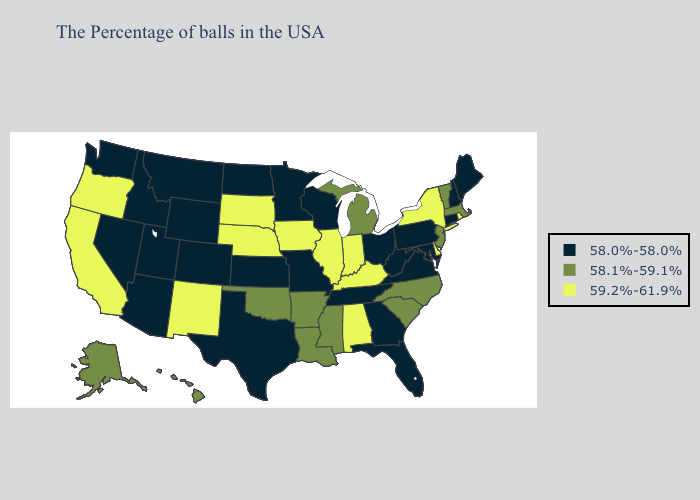What is the highest value in the USA?
Quick response, please. 59.2%-61.9%. What is the highest value in states that border Alabama?
Concise answer only. 58.1%-59.1%. Name the states that have a value in the range 59.2%-61.9%?
Be succinct. Rhode Island, New York, Delaware, Kentucky, Indiana, Alabama, Illinois, Iowa, Nebraska, South Dakota, New Mexico, California, Oregon. Name the states that have a value in the range 59.2%-61.9%?
Be succinct. Rhode Island, New York, Delaware, Kentucky, Indiana, Alabama, Illinois, Iowa, Nebraska, South Dakota, New Mexico, California, Oregon. Name the states that have a value in the range 58.1%-59.1%?
Write a very short answer. Massachusetts, Vermont, New Jersey, North Carolina, South Carolina, Michigan, Mississippi, Louisiana, Arkansas, Oklahoma, Alaska, Hawaii. Among the states that border South Dakota , does Minnesota have the lowest value?
Answer briefly. Yes. What is the lowest value in states that border New Mexico?
Quick response, please. 58.0%-58.0%. Name the states that have a value in the range 58.0%-58.0%?
Write a very short answer. Maine, New Hampshire, Connecticut, Maryland, Pennsylvania, Virginia, West Virginia, Ohio, Florida, Georgia, Tennessee, Wisconsin, Missouri, Minnesota, Kansas, Texas, North Dakota, Wyoming, Colorado, Utah, Montana, Arizona, Idaho, Nevada, Washington. Among the states that border Ohio , which have the highest value?
Give a very brief answer. Kentucky, Indiana. Does New Mexico have the lowest value in the USA?
Give a very brief answer. No. What is the highest value in states that border Nevada?
Short answer required. 59.2%-61.9%. Is the legend a continuous bar?
Short answer required. No. Name the states that have a value in the range 58.0%-58.0%?
Write a very short answer. Maine, New Hampshire, Connecticut, Maryland, Pennsylvania, Virginia, West Virginia, Ohio, Florida, Georgia, Tennessee, Wisconsin, Missouri, Minnesota, Kansas, Texas, North Dakota, Wyoming, Colorado, Utah, Montana, Arizona, Idaho, Nevada, Washington. Which states have the lowest value in the South?
Quick response, please. Maryland, Virginia, West Virginia, Florida, Georgia, Tennessee, Texas. Name the states that have a value in the range 58.1%-59.1%?
Be succinct. Massachusetts, Vermont, New Jersey, North Carolina, South Carolina, Michigan, Mississippi, Louisiana, Arkansas, Oklahoma, Alaska, Hawaii. 